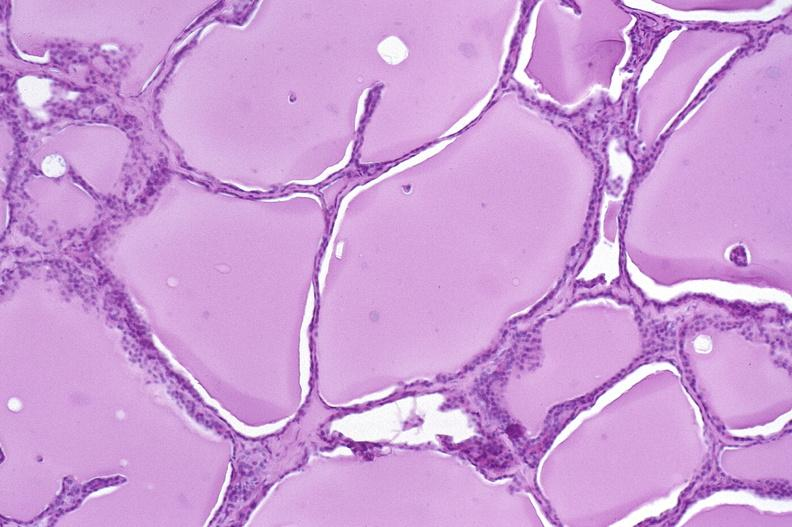s endocrine present?
Answer the question using a single word or phrase. Yes 